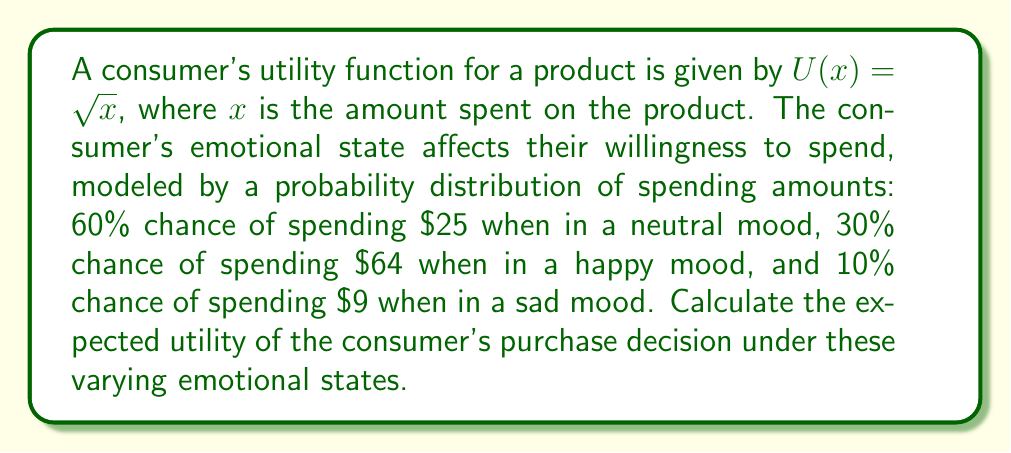Can you answer this question? To solve this problem, we need to follow these steps:

1. Calculate the utility for each spending amount:
   - Neutral mood: $U(25) = \sqrt{25} = 5$
   - Happy mood: $U(64) = \sqrt{64} = 8$
   - Sad mood: $U(9) = \sqrt{9} = 3$

2. Calculate the expected utility using the formula:
   $$E[U] = \sum_{i=1}^{n} p_i \cdot U(x_i)$$
   where $p_i$ is the probability of each outcome and $U(x_i)$ is the utility of each outcome.

3. Substitute the values:
   $$E[U] = 0.60 \cdot 5 + 0.30 \cdot 8 + 0.10 \cdot 3$$

4. Compute the result:
   $$E[U] = 3 + 2.4 + 0.3 = 5.7$$

Therefore, the expected utility of the consumer's purchase decision under varying emotional states is 5.7.
Answer: 5.7 